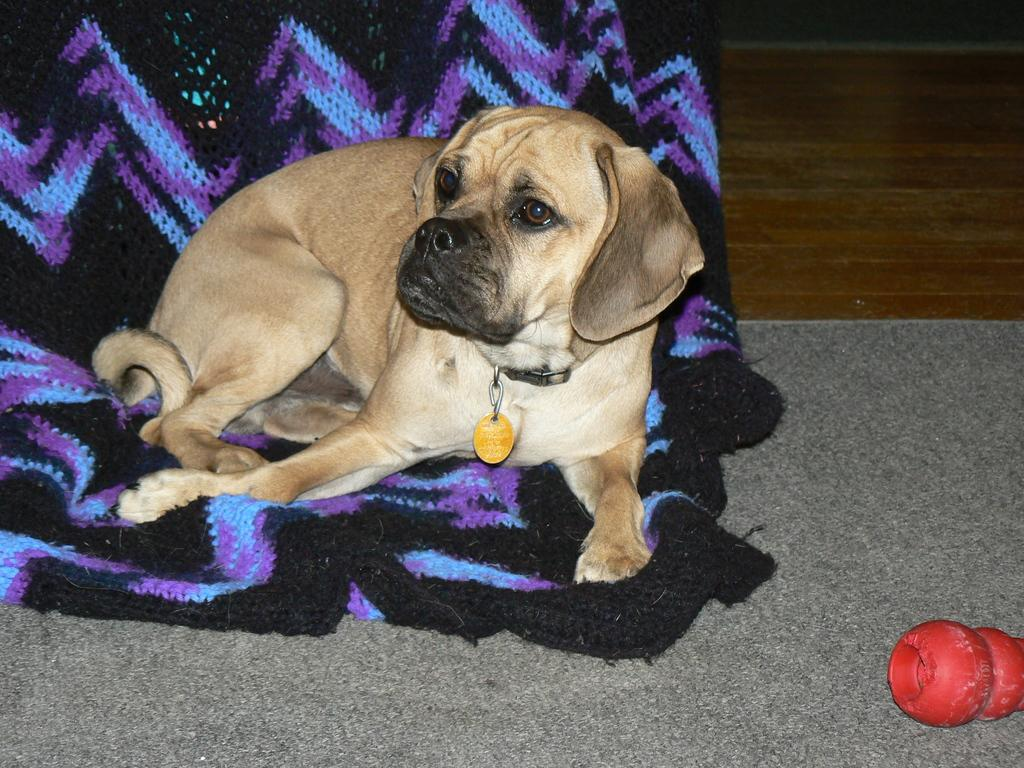What type of animal is in the image? There is a brown dog in the image. What is the dog resting on? The dog is on a cloth. Can you describe the colors of the cloth? The cloth has black, blue, and purple colors. What is the color of the object in front of the dog? The object in front of the dog is red. Does the cactus in the image have any spines? There is no cactus present in the image. 